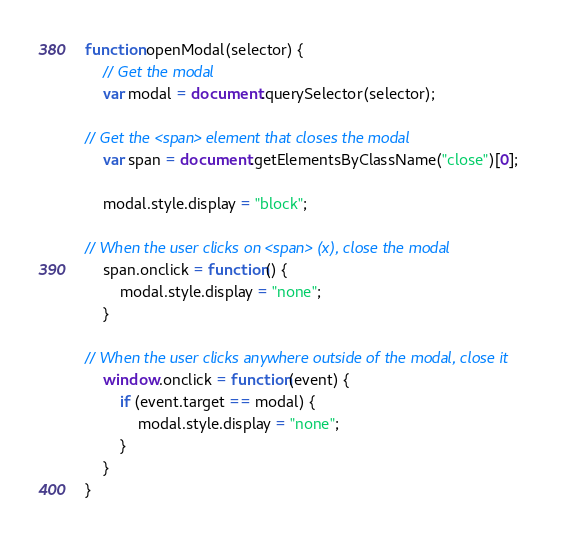Convert code to text. <code><loc_0><loc_0><loc_500><loc_500><_JavaScript_>function openModal(selector) {
	// Get the modal
	var modal = document.querySelector(selector);

// Get the <span> element that closes the modal
	var span = document.getElementsByClassName("close")[0];

	modal.style.display = "block";

// When the user clicks on <span> (x), close the modal
	span.onclick = function() {
		modal.style.display = "none";
	}

// When the user clicks anywhere outside of the modal, close it
	window.onclick = function(event) {
		if (event.target == modal) {
			modal.style.display = "none";
		}
	}
}</code> 